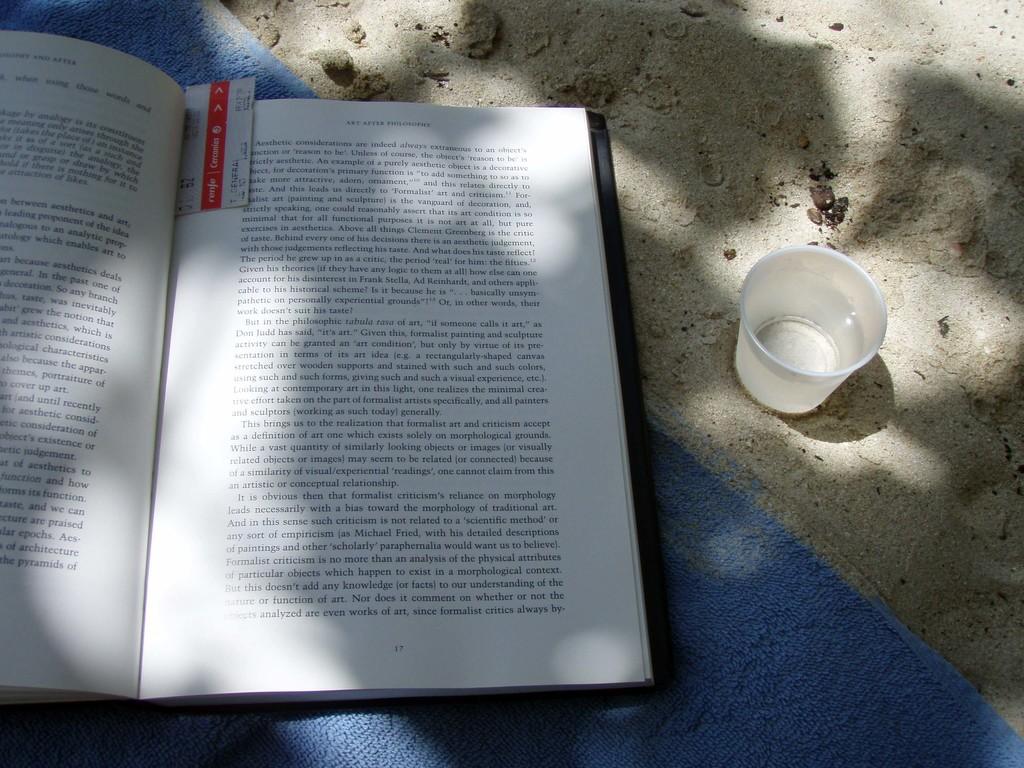Are there at least 4 paragraphs on the right page?
Ensure brevity in your answer.  Answering does not require reading text in the image. 